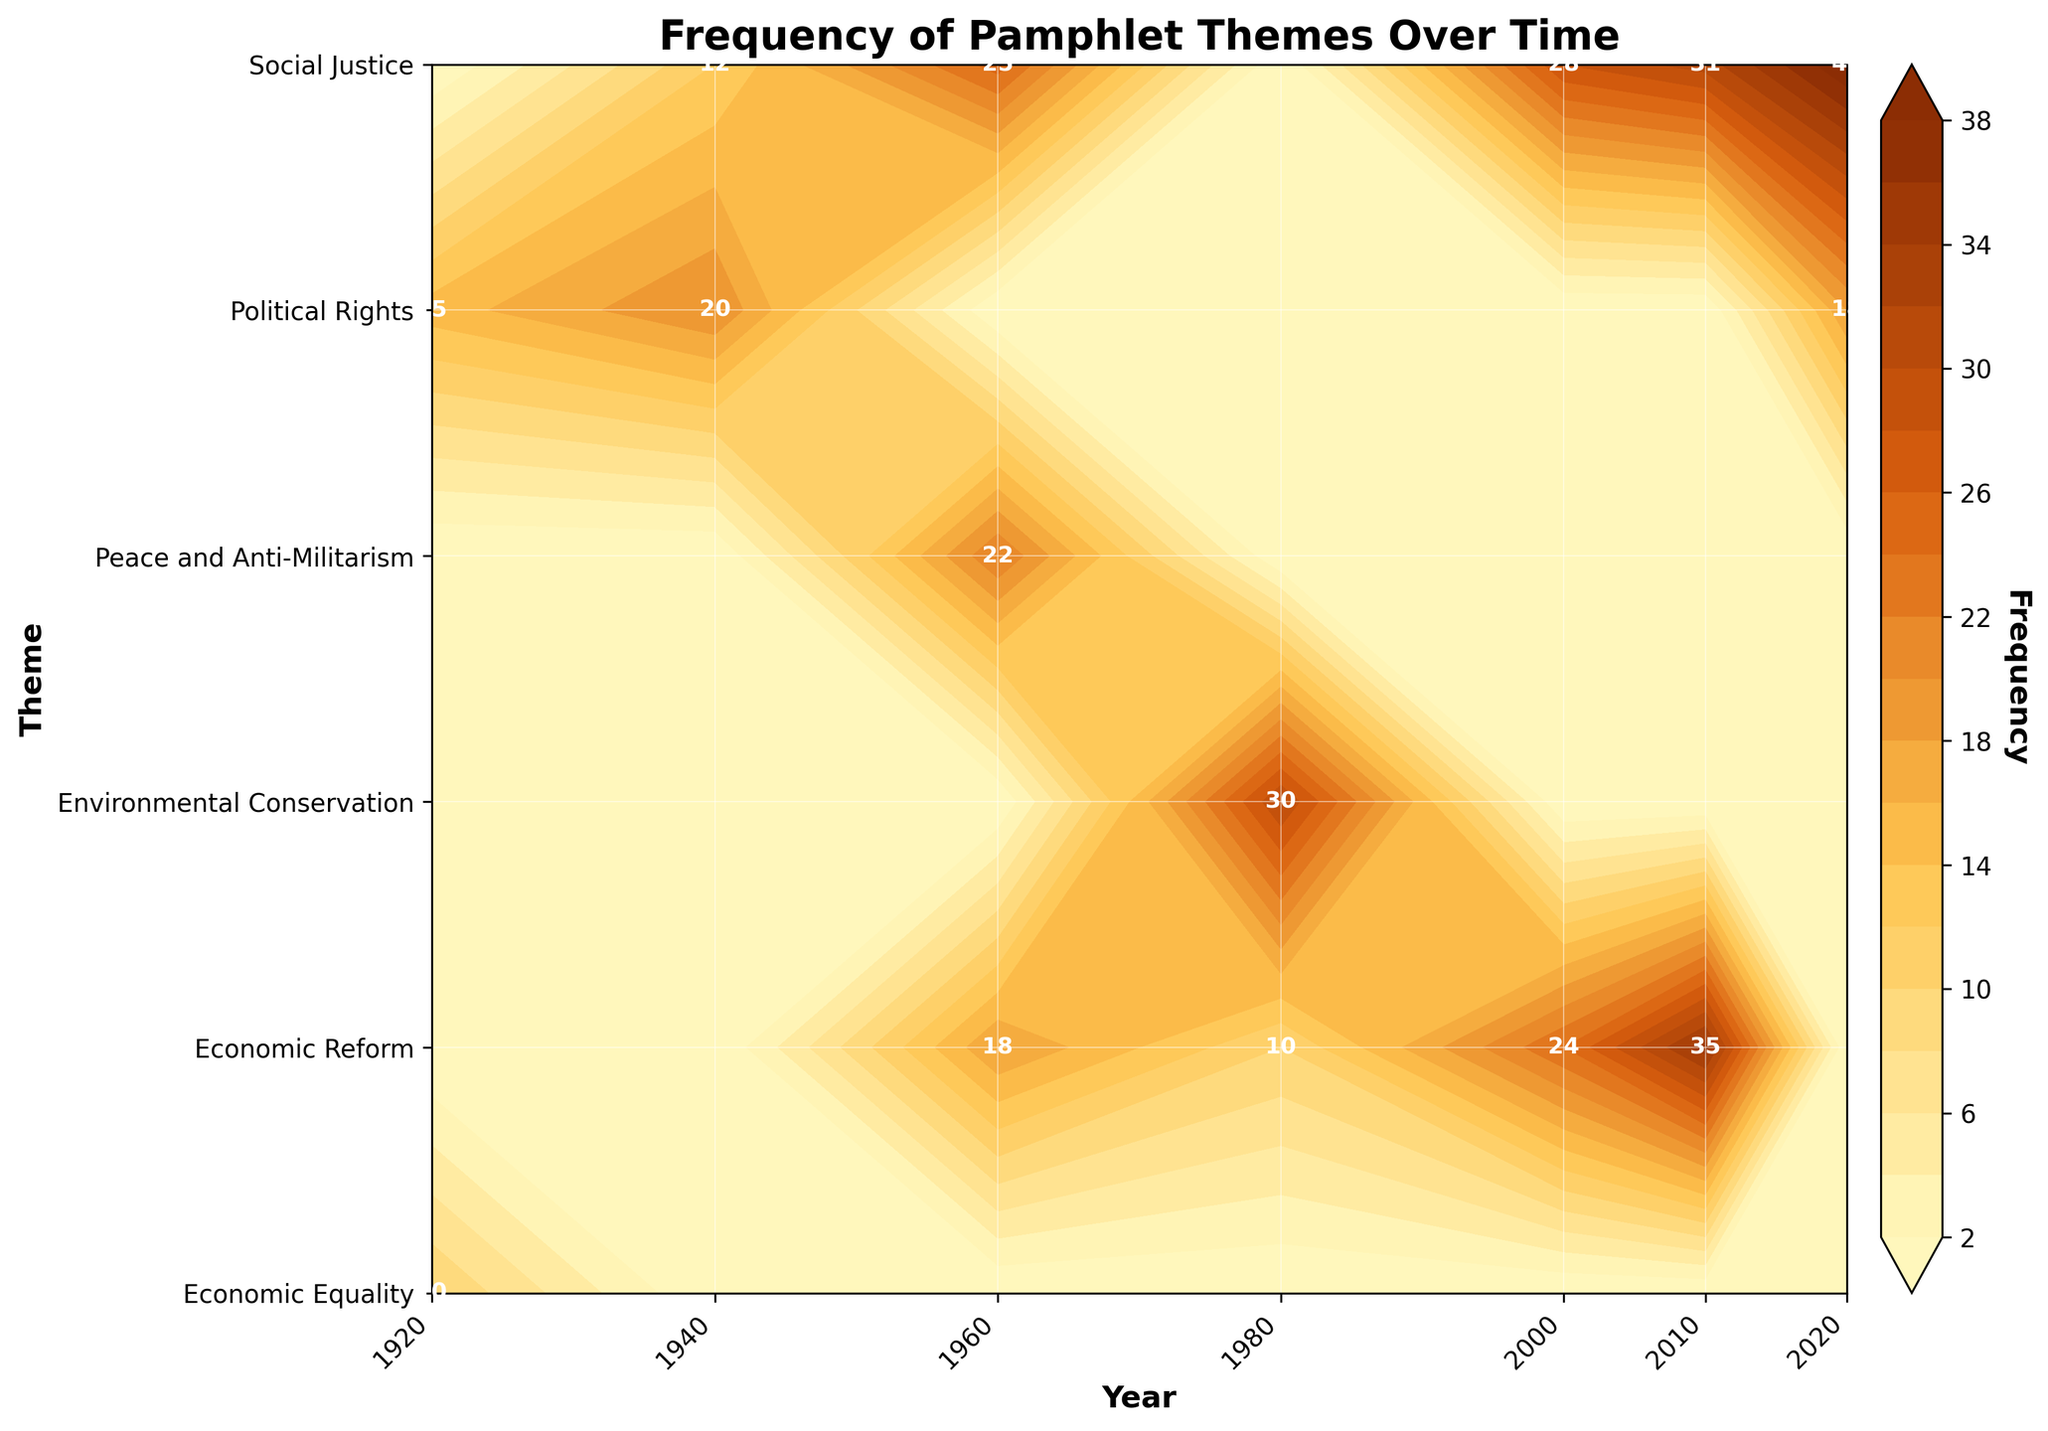what is the theme with the highest frequency in 2020? According to the plot, the theme with the highest color intensity in 2020 is "Social Justice," followed by "Political Rights".
Answer: Social Justice What is the lowest frequency theme in 1940? From the contour plot, the theme "Social Justice" at that time shows less intensity than "Political Rights". Eyeballing the frequencies, "Social Justice" appears to have a lower frequency.
Answer: Social Justice Which year has the highest frequency for the theme "Economic Reform"? By observing the color gradation over the years, the year 2010 shows the most intense color for "Economic Reform," indicating the highest frequency.
Answer: 2010 How many themes were covered in the year 1960? Observing the y-axis and the contour lines corresponding to the year 1960, you can see three themes: "Economic Reform," "Social Justice," and "Peace and Anti-Militarism."
Answer: 3 Which movement is associated with a peak in the "Environmental Conservation" theme? Noting the highest frequency for "Environmental Conservation" falls within 1980, cross-referencing this year with the movement list in the data, it’s the "Environmental Movement."
Answer: Environmental Movement Is the frequency of the theme "Social Justice" in 2000 greater than its frequency in 2010? Observing the color gradients denoting frequency, 2010 shows a more intense color for "Social Justice" than 2000, indicating a higher frequency.
Answer: No How does the frequency of "Political Rights" compare between 1920 and 2020? By comparing the color intensities, 1920 has a lighter shade than 2020, therefore "Political Rights" has a higher frequency in 2020.
Answer: Higher in 2020 What is the commonality visible in themes covered by the "Civil Rights Movement"? By looking at the year 1940 and 1960, the common themes "Social Justice" and "Political Rights" overlap across these years representing the "Civil Rights Movement."
Answer: Social Justice and Political Rights Identify the years during which the "Economic Reform" theme peaks? Observing the color intensity peak for "Economic Reform" theme over the years, it is highest at the years 2010 and 1960.
Answer: 2010 and 1960 Which theme has a wider distribution across the years: "Economic Reform" or "Political Rights"? Observing the contour plot, "Economic Reform" spans a broader range across multiple years (1940s to 2020s), whereas "Political Rights" is more clustered around specific years.
Answer: Economic Reform 